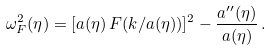<formula> <loc_0><loc_0><loc_500><loc_500>\omega _ { F } ^ { 2 } ( \eta ) = [ a ( \eta ) \, F ( k / a ( \eta ) ) ] ^ { 2 } - \frac { a ^ { \prime \prime } ( \eta ) } { a ( \eta ) } \, .</formula> 